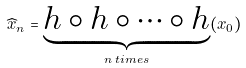<formula> <loc_0><loc_0><loc_500><loc_500>\widehat { x } _ { n } = \underbrace { h \circ h \circ \cdots \circ h } _ { n \, t i m e s } ( x _ { 0 } )</formula> 